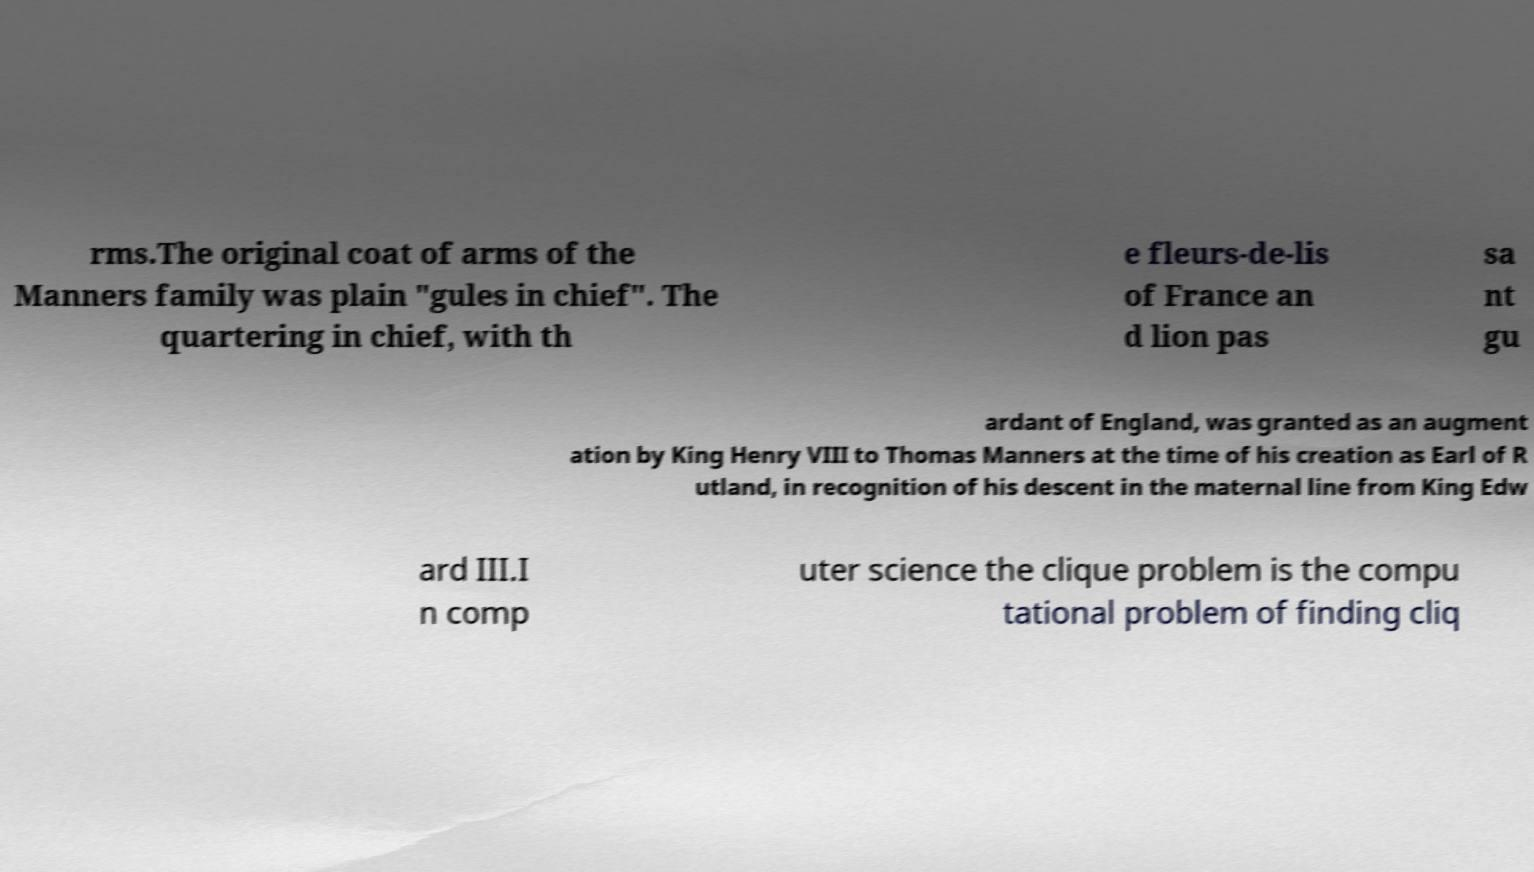I need the written content from this picture converted into text. Can you do that? rms.The original coat of arms of the Manners family was plain "gules in chief". The quartering in chief, with th e fleurs-de-lis of France an d lion pas sa nt gu ardant of England, was granted as an augment ation by King Henry VIII to Thomas Manners at the time of his creation as Earl of R utland, in recognition of his descent in the maternal line from King Edw ard III.I n comp uter science the clique problem is the compu tational problem of finding cliq 